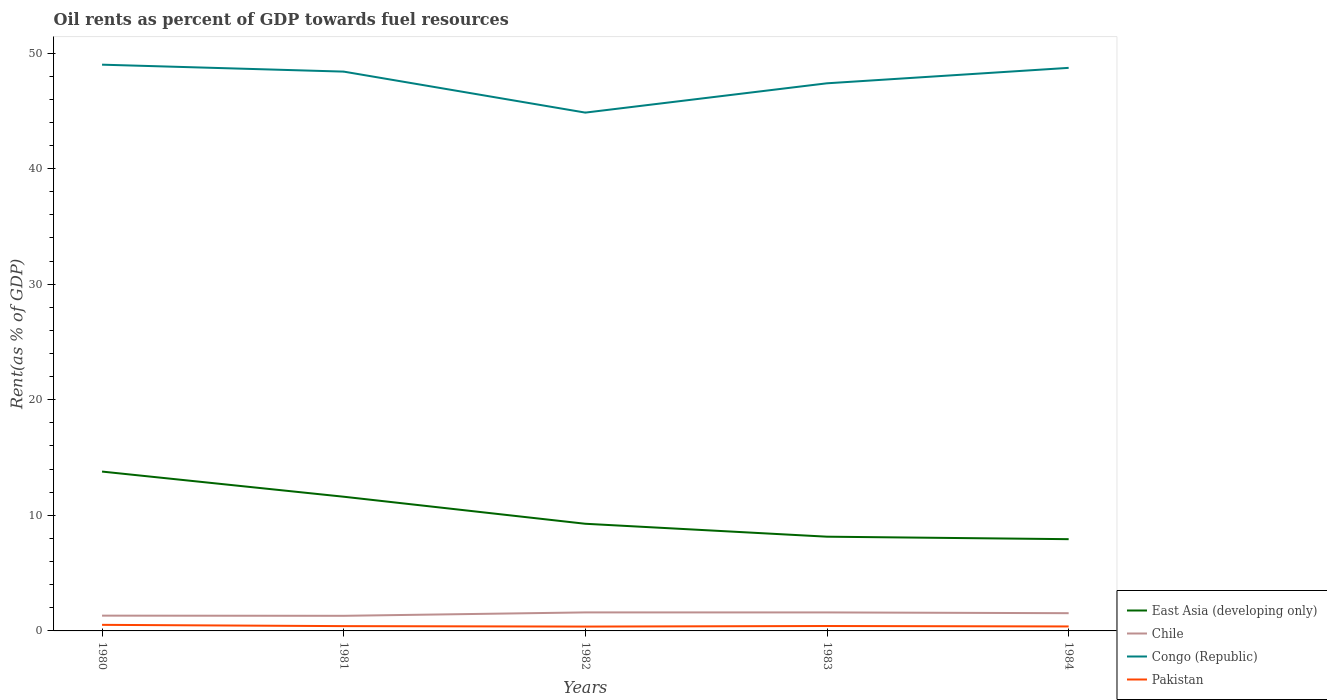Does the line corresponding to Congo (Republic) intersect with the line corresponding to Chile?
Keep it short and to the point. No. Across all years, what is the maximum oil rent in Chile?
Make the answer very short. 1.31. In which year was the oil rent in Pakistan maximum?
Make the answer very short. 1982. What is the total oil rent in Chile in the graph?
Provide a short and direct response. 0.02. What is the difference between the highest and the second highest oil rent in Pakistan?
Provide a succinct answer. 0.15. What is the difference between the highest and the lowest oil rent in Pakistan?
Your answer should be compact. 1. Is the oil rent in Pakistan strictly greater than the oil rent in Congo (Republic) over the years?
Keep it short and to the point. Yes. How many years are there in the graph?
Offer a very short reply. 5. What is the difference between two consecutive major ticks on the Y-axis?
Provide a short and direct response. 10. Does the graph contain any zero values?
Provide a succinct answer. No. Does the graph contain grids?
Your response must be concise. No. How are the legend labels stacked?
Your answer should be very brief. Vertical. What is the title of the graph?
Provide a succinct answer. Oil rents as percent of GDP towards fuel resources. What is the label or title of the Y-axis?
Your answer should be very brief. Rent(as % of GDP). What is the Rent(as % of GDP) of East Asia (developing only) in 1980?
Your response must be concise. 13.79. What is the Rent(as % of GDP) in Chile in 1980?
Your answer should be compact. 1.32. What is the Rent(as % of GDP) in Congo (Republic) in 1980?
Give a very brief answer. 48.99. What is the Rent(as % of GDP) of Pakistan in 1980?
Offer a terse response. 0.53. What is the Rent(as % of GDP) of East Asia (developing only) in 1981?
Keep it short and to the point. 11.61. What is the Rent(as % of GDP) of Chile in 1981?
Offer a very short reply. 1.31. What is the Rent(as % of GDP) in Congo (Republic) in 1981?
Offer a very short reply. 48.39. What is the Rent(as % of GDP) of Pakistan in 1981?
Offer a very short reply. 0.41. What is the Rent(as % of GDP) of East Asia (developing only) in 1982?
Give a very brief answer. 9.27. What is the Rent(as % of GDP) of Chile in 1982?
Offer a terse response. 1.6. What is the Rent(as % of GDP) in Congo (Republic) in 1982?
Your answer should be compact. 44.84. What is the Rent(as % of GDP) in Pakistan in 1982?
Your response must be concise. 0.38. What is the Rent(as % of GDP) of East Asia (developing only) in 1983?
Your response must be concise. 8.15. What is the Rent(as % of GDP) of Chile in 1983?
Your response must be concise. 1.6. What is the Rent(as % of GDP) in Congo (Republic) in 1983?
Provide a short and direct response. 47.38. What is the Rent(as % of GDP) in Pakistan in 1983?
Provide a short and direct response. 0.43. What is the Rent(as % of GDP) of East Asia (developing only) in 1984?
Offer a terse response. 7.94. What is the Rent(as % of GDP) of Chile in 1984?
Offer a terse response. 1.53. What is the Rent(as % of GDP) in Congo (Republic) in 1984?
Offer a terse response. 48.72. What is the Rent(as % of GDP) of Pakistan in 1984?
Your answer should be compact. 0.39. Across all years, what is the maximum Rent(as % of GDP) of East Asia (developing only)?
Give a very brief answer. 13.79. Across all years, what is the maximum Rent(as % of GDP) of Chile?
Provide a short and direct response. 1.6. Across all years, what is the maximum Rent(as % of GDP) in Congo (Republic)?
Your answer should be very brief. 48.99. Across all years, what is the maximum Rent(as % of GDP) in Pakistan?
Offer a terse response. 0.53. Across all years, what is the minimum Rent(as % of GDP) in East Asia (developing only)?
Offer a terse response. 7.94. Across all years, what is the minimum Rent(as % of GDP) in Chile?
Your answer should be very brief. 1.31. Across all years, what is the minimum Rent(as % of GDP) in Congo (Republic)?
Provide a succinct answer. 44.84. Across all years, what is the minimum Rent(as % of GDP) in Pakistan?
Keep it short and to the point. 0.38. What is the total Rent(as % of GDP) in East Asia (developing only) in the graph?
Provide a succinct answer. 50.76. What is the total Rent(as % of GDP) in Chile in the graph?
Provide a succinct answer. 7.36. What is the total Rent(as % of GDP) in Congo (Republic) in the graph?
Make the answer very short. 238.33. What is the total Rent(as % of GDP) of Pakistan in the graph?
Give a very brief answer. 2.13. What is the difference between the Rent(as % of GDP) of East Asia (developing only) in 1980 and that in 1981?
Your response must be concise. 2.18. What is the difference between the Rent(as % of GDP) of Chile in 1980 and that in 1981?
Offer a terse response. 0.02. What is the difference between the Rent(as % of GDP) of Congo (Republic) in 1980 and that in 1981?
Make the answer very short. 0.6. What is the difference between the Rent(as % of GDP) of Pakistan in 1980 and that in 1981?
Give a very brief answer. 0.11. What is the difference between the Rent(as % of GDP) in East Asia (developing only) in 1980 and that in 1982?
Give a very brief answer. 4.52. What is the difference between the Rent(as % of GDP) in Chile in 1980 and that in 1982?
Keep it short and to the point. -0.28. What is the difference between the Rent(as % of GDP) of Congo (Republic) in 1980 and that in 1982?
Provide a succinct answer. 4.15. What is the difference between the Rent(as % of GDP) in Pakistan in 1980 and that in 1982?
Make the answer very short. 0.15. What is the difference between the Rent(as % of GDP) in East Asia (developing only) in 1980 and that in 1983?
Offer a terse response. 5.63. What is the difference between the Rent(as % of GDP) of Chile in 1980 and that in 1983?
Offer a very short reply. -0.28. What is the difference between the Rent(as % of GDP) in Congo (Republic) in 1980 and that in 1983?
Ensure brevity in your answer.  1.61. What is the difference between the Rent(as % of GDP) in Pakistan in 1980 and that in 1983?
Your response must be concise. 0.1. What is the difference between the Rent(as % of GDP) of East Asia (developing only) in 1980 and that in 1984?
Your answer should be compact. 5.85. What is the difference between the Rent(as % of GDP) in Chile in 1980 and that in 1984?
Keep it short and to the point. -0.21. What is the difference between the Rent(as % of GDP) in Congo (Republic) in 1980 and that in 1984?
Offer a very short reply. 0.28. What is the difference between the Rent(as % of GDP) in Pakistan in 1980 and that in 1984?
Ensure brevity in your answer.  0.14. What is the difference between the Rent(as % of GDP) of East Asia (developing only) in 1981 and that in 1982?
Offer a terse response. 2.34. What is the difference between the Rent(as % of GDP) in Chile in 1981 and that in 1982?
Provide a short and direct response. -0.29. What is the difference between the Rent(as % of GDP) of Congo (Republic) in 1981 and that in 1982?
Your answer should be very brief. 3.55. What is the difference between the Rent(as % of GDP) of Pakistan in 1981 and that in 1982?
Provide a succinct answer. 0.04. What is the difference between the Rent(as % of GDP) of East Asia (developing only) in 1981 and that in 1983?
Your answer should be compact. 3.46. What is the difference between the Rent(as % of GDP) of Chile in 1981 and that in 1983?
Your response must be concise. -0.29. What is the difference between the Rent(as % of GDP) of Congo (Republic) in 1981 and that in 1983?
Offer a very short reply. 1.01. What is the difference between the Rent(as % of GDP) in Pakistan in 1981 and that in 1983?
Your response must be concise. -0.01. What is the difference between the Rent(as % of GDP) of East Asia (developing only) in 1981 and that in 1984?
Make the answer very short. 3.67. What is the difference between the Rent(as % of GDP) in Chile in 1981 and that in 1984?
Offer a very short reply. -0.23. What is the difference between the Rent(as % of GDP) of Congo (Republic) in 1981 and that in 1984?
Provide a succinct answer. -0.32. What is the difference between the Rent(as % of GDP) of Pakistan in 1981 and that in 1984?
Offer a terse response. 0.03. What is the difference between the Rent(as % of GDP) of East Asia (developing only) in 1982 and that in 1983?
Provide a short and direct response. 1.12. What is the difference between the Rent(as % of GDP) of Chile in 1982 and that in 1983?
Your response must be concise. 0. What is the difference between the Rent(as % of GDP) in Congo (Republic) in 1982 and that in 1983?
Your answer should be very brief. -2.54. What is the difference between the Rent(as % of GDP) of Pakistan in 1982 and that in 1983?
Keep it short and to the point. -0.05. What is the difference between the Rent(as % of GDP) of East Asia (developing only) in 1982 and that in 1984?
Provide a short and direct response. 1.33. What is the difference between the Rent(as % of GDP) of Chile in 1982 and that in 1984?
Provide a succinct answer. 0.07. What is the difference between the Rent(as % of GDP) of Congo (Republic) in 1982 and that in 1984?
Make the answer very short. -3.87. What is the difference between the Rent(as % of GDP) in Pakistan in 1982 and that in 1984?
Make the answer very short. -0.01. What is the difference between the Rent(as % of GDP) of East Asia (developing only) in 1983 and that in 1984?
Keep it short and to the point. 0.22. What is the difference between the Rent(as % of GDP) of Chile in 1983 and that in 1984?
Make the answer very short. 0.07. What is the difference between the Rent(as % of GDP) of Congo (Republic) in 1983 and that in 1984?
Your response must be concise. -1.34. What is the difference between the Rent(as % of GDP) of Pakistan in 1983 and that in 1984?
Keep it short and to the point. 0.04. What is the difference between the Rent(as % of GDP) of East Asia (developing only) in 1980 and the Rent(as % of GDP) of Chile in 1981?
Make the answer very short. 12.48. What is the difference between the Rent(as % of GDP) of East Asia (developing only) in 1980 and the Rent(as % of GDP) of Congo (Republic) in 1981?
Your answer should be compact. -34.61. What is the difference between the Rent(as % of GDP) of East Asia (developing only) in 1980 and the Rent(as % of GDP) of Pakistan in 1981?
Give a very brief answer. 13.37. What is the difference between the Rent(as % of GDP) in Chile in 1980 and the Rent(as % of GDP) in Congo (Republic) in 1981?
Provide a succinct answer. -47.07. What is the difference between the Rent(as % of GDP) in Chile in 1980 and the Rent(as % of GDP) in Pakistan in 1981?
Your response must be concise. 0.91. What is the difference between the Rent(as % of GDP) in Congo (Republic) in 1980 and the Rent(as % of GDP) in Pakistan in 1981?
Provide a succinct answer. 48.58. What is the difference between the Rent(as % of GDP) of East Asia (developing only) in 1980 and the Rent(as % of GDP) of Chile in 1982?
Offer a very short reply. 12.19. What is the difference between the Rent(as % of GDP) in East Asia (developing only) in 1980 and the Rent(as % of GDP) in Congo (Republic) in 1982?
Your response must be concise. -31.06. What is the difference between the Rent(as % of GDP) in East Asia (developing only) in 1980 and the Rent(as % of GDP) in Pakistan in 1982?
Offer a very short reply. 13.41. What is the difference between the Rent(as % of GDP) of Chile in 1980 and the Rent(as % of GDP) of Congo (Republic) in 1982?
Your answer should be very brief. -43.52. What is the difference between the Rent(as % of GDP) of Chile in 1980 and the Rent(as % of GDP) of Pakistan in 1982?
Your answer should be very brief. 0.95. What is the difference between the Rent(as % of GDP) in Congo (Republic) in 1980 and the Rent(as % of GDP) in Pakistan in 1982?
Make the answer very short. 48.62. What is the difference between the Rent(as % of GDP) in East Asia (developing only) in 1980 and the Rent(as % of GDP) in Chile in 1983?
Your answer should be very brief. 12.19. What is the difference between the Rent(as % of GDP) of East Asia (developing only) in 1980 and the Rent(as % of GDP) of Congo (Republic) in 1983?
Provide a short and direct response. -33.59. What is the difference between the Rent(as % of GDP) of East Asia (developing only) in 1980 and the Rent(as % of GDP) of Pakistan in 1983?
Give a very brief answer. 13.36. What is the difference between the Rent(as % of GDP) in Chile in 1980 and the Rent(as % of GDP) in Congo (Republic) in 1983?
Your answer should be very brief. -46.06. What is the difference between the Rent(as % of GDP) in Chile in 1980 and the Rent(as % of GDP) in Pakistan in 1983?
Your answer should be very brief. 0.9. What is the difference between the Rent(as % of GDP) in Congo (Republic) in 1980 and the Rent(as % of GDP) in Pakistan in 1983?
Provide a succinct answer. 48.57. What is the difference between the Rent(as % of GDP) in East Asia (developing only) in 1980 and the Rent(as % of GDP) in Chile in 1984?
Offer a very short reply. 12.25. What is the difference between the Rent(as % of GDP) of East Asia (developing only) in 1980 and the Rent(as % of GDP) of Congo (Republic) in 1984?
Your answer should be compact. -34.93. What is the difference between the Rent(as % of GDP) of East Asia (developing only) in 1980 and the Rent(as % of GDP) of Pakistan in 1984?
Ensure brevity in your answer.  13.4. What is the difference between the Rent(as % of GDP) in Chile in 1980 and the Rent(as % of GDP) in Congo (Republic) in 1984?
Provide a short and direct response. -47.39. What is the difference between the Rent(as % of GDP) of Chile in 1980 and the Rent(as % of GDP) of Pakistan in 1984?
Ensure brevity in your answer.  0.94. What is the difference between the Rent(as % of GDP) in Congo (Republic) in 1980 and the Rent(as % of GDP) in Pakistan in 1984?
Make the answer very short. 48.61. What is the difference between the Rent(as % of GDP) in East Asia (developing only) in 1981 and the Rent(as % of GDP) in Chile in 1982?
Give a very brief answer. 10.01. What is the difference between the Rent(as % of GDP) in East Asia (developing only) in 1981 and the Rent(as % of GDP) in Congo (Republic) in 1982?
Offer a very short reply. -33.23. What is the difference between the Rent(as % of GDP) of East Asia (developing only) in 1981 and the Rent(as % of GDP) of Pakistan in 1982?
Offer a very short reply. 11.23. What is the difference between the Rent(as % of GDP) in Chile in 1981 and the Rent(as % of GDP) in Congo (Republic) in 1982?
Your answer should be compact. -43.54. What is the difference between the Rent(as % of GDP) in Chile in 1981 and the Rent(as % of GDP) in Pakistan in 1982?
Provide a succinct answer. 0.93. What is the difference between the Rent(as % of GDP) of Congo (Republic) in 1981 and the Rent(as % of GDP) of Pakistan in 1982?
Your answer should be compact. 48.02. What is the difference between the Rent(as % of GDP) of East Asia (developing only) in 1981 and the Rent(as % of GDP) of Chile in 1983?
Ensure brevity in your answer.  10.01. What is the difference between the Rent(as % of GDP) of East Asia (developing only) in 1981 and the Rent(as % of GDP) of Congo (Republic) in 1983?
Your response must be concise. -35.77. What is the difference between the Rent(as % of GDP) of East Asia (developing only) in 1981 and the Rent(as % of GDP) of Pakistan in 1983?
Keep it short and to the point. 11.19. What is the difference between the Rent(as % of GDP) of Chile in 1981 and the Rent(as % of GDP) of Congo (Republic) in 1983?
Keep it short and to the point. -46.07. What is the difference between the Rent(as % of GDP) of Chile in 1981 and the Rent(as % of GDP) of Pakistan in 1983?
Give a very brief answer. 0.88. What is the difference between the Rent(as % of GDP) of Congo (Republic) in 1981 and the Rent(as % of GDP) of Pakistan in 1983?
Ensure brevity in your answer.  47.97. What is the difference between the Rent(as % of GDP) in East Asia (developing only) in 1981 and the Rent(as % of GDP) in Chile in 1984?
Give a very brief answer. 10.08. What is the difference between the Rent(as % of GDP) of East Asia (developing only) in 1981 and the Rent(as % of GDP) of Congo (Republic) in 1984?
Provide a short and direct response. -37.11. What is the difference between the Rent(as % of GDP) of East Asia (developing only) in 1981 and the Rent(as % of GDP) of Pakistan in 1984?
Ensure brevity in your answer.  11.22. What is the difference between the Rent(as % of GDP) in Chile in 1981 and the Rent(as % of GDP) in Congo (Republic) in 1984?
Ensure brevity in your answer.  -47.41. What is the difference between the Rent(as % of GDP) of Chile in 1981 and the Rent(as % of GDP) of Pakistan in 1984?
Your response must be concise. 0.92. What is the difference between the Rent(as % of GDP) of Congo (Republic) in 1981 and the Rent(as % of GDP) of Pakistan in 1984?
Your response must be concise. 48.01. What is the difference between the Rent(as % of GDP) in East Asia (developing only) in 1982 and the Rent(as % of GDP) in Chile in 1983?
Keep it short and to the point. 7.67. What is the difference between the Rent(as % of GDP) in East Asia (developing only) in 1982 and the Rent(as % of GDP) in Congo (Republic) in 1983?
Give a very brief answer. -38.11. What is the difference between the Rent(as % of GDP) in East Asia (developing only) in 1982 and the Rent(as % of GDP) in Pakistan in 1983?
Ensure brevity in your answer.  8.85. What is the difference between the Rent(as % of GDP) of Chile in 1982 and the Rent(as % of GDP) of Congo (Republic) in 1983?
Offer a very short reply. -45.78. What is the difference between the Rent(as % of GDP) in Chile in 1982 and the Rent(as % of GDP) in Pakistan in 1983?
Provide a succinct answer. 1.18. What is the difference between the Rent(as % of GDP) of Congo (Republic) in 1982 and the Rent(as % of GDP) of Pakistan in 1983?
Keep it short and to the point. 44.42. What is the difference between the Rent(as % of GDP) of East Asia (developing only) in 1982 and the Rent(as % of GDP) of Chile in 1984?
Keep it short and to the point. 7.74. What is the difference between the Rent(as % of GDP) in East Asia (developing only) in 1982 and the Rent(as % of GDP) in Congo (Republic) in 1984?
Provide a succinct answer. -39.45. What is the difference between the Rent(as % of GDP) of East Asia (developing only) in 1982 and the Rent(as % of GDP) of Pakistan in 1984?
Provide a short and direct response. 8.88. What is the difference between the Rent(as % of GDP) of Chile in 1982 and the Rent(as % of GDP) of Congo (Republic) in 1984?
Ensure brevity in your answer.  -47.12. What is the difference between the Rent(as % of GDP) in Chile in 1982 and the Rent(as % of GDP) in Pakistan in 1984?
Give a very brief answer. 1.21. What is the difference between the Rent(as % of GDP) of Congo (Republic) in 1982 and the Rent(as % of GDP) of Pakistan in 1984?
Ensure brevity in your answer.  44.46. What is the difference between the Rent(as % of GDP) of East Asia (developing only) in 1983 and the Rent(as % of GDP) of Chile in 1984?
Provide a short and direct response. 6.62. What is the difference between the Rent(as % of GDP) of East Asia (developing only) in 1983 and the Rent(as % of GDP) of Congo (Republic) in 1984?
Keep it short and to the point. -40.56. What is the difference between the Rent(as % of GDP) of East Asia (developing only) in 1983 and the Rent(as % of GDP) of Pakistan in 1984?
Ensure brevity in your answer.  7.77. What is the difference between the Rent(as % of GDP) of Chile in 1983 and the Rent(as % of GDP) of Congo (Republic) in 1984?
Provide a succinct answer. -47.12. What is the difference between the Rent(as % of GDP) in Chile in 1983 and the Rent(as % of GDP) in Pakistan in 1984?
Your answer should be compact. 1.21. What is the difference between the Rent(as % of GDP) of Congo (Republic) in 1983 and the Rent(as % of GDP) of Pakistan in 1984?
Provide a succinct answer. 46.99. What is the average Rent(as % of GDP) in East Asia (developing only) per year?
Give a very brief answer. 10.15. What is the average Rent(as % of GDP) of Chile per year?
Offer a very short reply. 1.47. What is the average Rent(as % of GDP) of Congo (Republic) per year?
Keep it short and to the point. 47.67. What is the average Rent(as % of GDP) of Pakistan per year?
Ensure brevity in your answer.  0.43. In the year 1980, what is the difference between the Rent(as % of GDP) of East Asia (developing only) and Rent(as % of GDP) of Chile?
Make the answer very short. 12.47. In the year 1980, what is the difference between the Rent(as % of GDP) in East Asia (developing only) and Rent(as % of GDP) in Congo (Republic)?
Your response must be concise. -35.21. In the year 1980, what is the difference between the Rent(as % of GDP) in East Asia (developing only) and Rent(as % of GDP) in Pakistan?
Ensure brevity in your answer.  13.26. In the year 1980, what is the difference between the Rent(as % of GDP) of Chile and Rent(as % of GDP) of Congo (Republic)?
Give a very brief answer. -47.67. In the year 1980, what is the difference between the Rent(as % of GDP) of Chile and Rent(as % of GDP) of Pakistan?
Offer a very short reply. 0.8. In the year 1980, what is the difference between the Rent(as % of GDP) of Congo (Republic) and Rent(as % of GDP) of Pakistan?
Offer a terse response. 48.47. In the year 1981, what is the difference between the Rent(as % of GDP) of East Asia (developing only) and Rent(as % of GDP) of Chile?
Your answer should be very brief. 10.3. In the year 1981, what is the difference between the Rent(as % of GDP) of East Asia (developing only) and Rent(as % of GDP) of Congo (Republic)?
Offer a terse response. -36.78. In the year 1981, what is the difference between the Rent(as % of GDP) of East Asia (developing only) and Rent(as % of GDP) of Pakistan?
Provide a short and direct response. 11.2. In the year 1981, what is the difference between the Rent(as % of GDP) of Chile and Rent(as % of GDP) of Congo (Republic)?
Offer a terse response. -47.09. In the year 1981, what is the difference between the Rent(as % of GDP) of Chile and Rent(as % of GDP) of Pakistan?
Your answer should be compact. 0.89. In the year 1981, what is the difference between the Rent(as % of GDP) in Congo (Republic) and Rent(as % of GDP) in Pakistan?
Your answer should be very brief. 47.98. In the year 1982, what is the difference between the Rent(as % of GDP) in East Asia (developing only) and Rent(as % of GDP) in Chile?
Offer a very short reply. 7.67. In the year 1982, what is the difference between the Rent(as % of GDP) in East Asia (developing only) and Rent(as % of GDP) in Congo (Republic)?
Your response must be concise. -35.57. In the year 1982, what is the difference between the Rent(as % of GDP) in East Asia (developing only) and Rent(as % of GDP) in Pakistan?
Provide a succinct answer. 8.9. In the year 1982, what is the difference between the Rent(as % of GDP) of Chile and Rent(as % of GDP) of Congo (Republic)?
Provide a short and direct response. -43.24. In the year 1982, what is the difference between the Rent(as % of GDP) in Chile and Rent(as % of GDP) in Pakistan?
Your response must be concise. 1.23. In the year 1982, what is the difference between the Rent(as % of GDP) in Congo (Republic) and Rent(as % of GDP) in Pakistan?
Your response must be concise. 44.47. In the year 1983, what is the difference between the Rent(as % of GDP) of East Asia (developing only) and Rent(as % of GDP) of Chile?
Give a very brief answer. 6.55. In the year 1983, what is the difference between the Rent(as % of GDP) of East Asia (developing only) and Rent(as % of GDP) of Congo (Republic)?
Provide a succinct answer. -39.23. In the year 1983, what is the difference between the Rent(as % of GDP) in East Asia (developing only) and Rent(as % of GDP) in Pakistan?
Give a very brief answer. 7.73. In the year 1983, what is the difference between the Rent(as % of GDP) of Chile and Rent(as % of GDP) of Congo (Republic)?
Your answer should be compact. -45.78. In the year 1983, what is the difference between the Rent(as % of GDP) in Chile and Rent(as % of GDP) in Pakistan?
Your answer should be very brief. 1.18. In the year 1983, what is the difference between the Rent(as % of GDP) of Congo (Republic) and Rent(as % of GDP) of Pakistan?
Ensure brevity in your answer.  46.96. In the year 1984, what is the difference between the Rent(as % of GDP) in East Asia (developing only) and Rent(as % of GDP) in Chile?
Make the answer very short. 6.4. In the year 1984, what is the difference between the Rent(as % of GDP) of East Asia (developing only) and Rent(as % of GDP) of Congo (Republic)?
Offer a terse response. -40.78. In the year 1984, what is the difference between the Rent(as % of GDP) in East Asia (developing only) and Rent(as % of GDP) in Pakistan?
Provide a succinct answer. 7.55. In the year 1984, what is the difference between the Rent(as % of GDP) in Chile and Rent(as % of GDP) in Congo (Republic)?
Your response must be concise. -47.18. In the year 1984, what is the difference between the Rent(as % of GDP) of Chile and Rent(as % of GDP) of Pakistan?
Keep it short and to the point. 1.15. In the year 1984, what is the difference between the Rent(as % of GDP) in Congo (Republic) and Rent(as % of GDP) in Pakistan?
Offer a very short reply. 48.33. What is the ratio of the Rent(as % of GDP) in East Asia (developing only) in 1980 to that in 1981?
Ensure brevity in your answer.  1.19. What is the ratio of the Rent(as % of GDP) in Chile in 1980 to that in 1981?
Provide a succinct answer. 1.01. What is the ratio of the Rent(as % of GDP) of Congo (Republic) in 1980 to that in 1981?
Your answer should be very brief. 1.01. What is the ratio of the Rent(as % of GDP) in Pakistan in 1980 to that in 1981?
Offer a terse response. 1.27. What is the ratio of the Rent(as % of GDP) in East Asia (developing only) in 1980 to that in 1982?
Offer a terse response. 1.49. What is the ratio of the Rent(as % of GDP) of Chile in 1980 to that in 1982?
Provide a short and direct response. 0.83. What is the ratio of the Rent(as % of GDP) in Congo (Republic) in 1980 to that in 1982?
Give a very brief answer. 1.09. What is the ratio of the Rent(as % of GDP) in Pakistan in 1980 to that in 1982?
Your answer should be compact. 1.4. What is the ratio of the Rent(as % of GDP) of East Asia (developing only) in 1980 to that in 1983?
Offer a terse response. 1.69. What is the ratio of the Rent(as % of GDP) of Chile in 1980 to that in 1983?
Your answer should be very brief. 0.83. What is the ratio of the Rent(as % of GDP) of Congo (Republic) in 1980 to that in 1983?
Keep it short and to the point. 1.03. What is the ratio of the Rent(as % of GDP) in Pakistan in 1980 to that in 1983?
Offer a very short reply. 1.24. What is the ratio of the Rent(as % of GDP) of East Asia (developing only) in 1980 to that in 1984?
Offer a terse response. 1.74. What is the ratio of the Rent(as % of GDP) in Chile in 1980 to that in 1984?
Make the answer very short. 0.86. What is the ratio of the Rent(as % of GDP) in Pakistan in 1980 to that in 1984?
Ensure brevity in your answer.  1.36. What is the ratio of the Rent(as % of GDP) of East Asia (developing only) in 1981 to that in 1982?
Offer a very short reply. 1.25. What is the ratio of the Rent(as % of GDP) in Chile in 1981 to that in 1982?
Your answer should be compact. 0.82. What is the ratio of the Rent(as % of GDP) in Congo (Republic) in 1981 to that in 1982?
Give a very brief answer. 1.08. What is the ratio of the Rent(as % of GDP) of Pakistan in 1981 to that in 1982?
Your response must be concise. 1.1. What is the ratio of the Rent(as % of GDP) of East Asia (developing only) in 1981 to that in 1983?
Offer a terse response. 1.42. What is the ratio of the Rent(as % of GDP) in Chile in 1981 to that in 1983?
Offer a terse response. 0.82. What is the ratio of the Rent(as % of GDP) in Congo (Republic) in 1981 to that in 1983?
Give a very brief answer. 1.02. What is the ratio of the Rent(as % of GDP) in Pakistan in 1981 to that in 1983?
Your answer should be very brief. 0.97. What is the ratio of the Rent(as % of GDP) in East Asia (developing only) in 1981 to that in 1984?
Make the answer very short. 1.46. What is the ratio of the Rent(as % of GDP) of Chile in 1981 to that in 1984?
Your answer should be very brief. 0.85. What is the ratio of the Rent(as % of GDP) in Pakistan in 1981 to that in 1984?
Provide a succinct answer. 1.07. What is the ratio of the Rent(as % of GDP) in East Asia (developing only) in 1982 to that in 1983?
Your answer should be very brief. 1.14. What is the ratio of the Rent(as % of GDP) of Chile in 1982 to that in 1983?
Provide a succinct answer. 1. What is the ratio of the Rent(as % of GDP) of Congo (Republic) in 1982 to that in 1983?
Your response must be concise. 0.95. What is the ratio of the Rent(as % of GDP) in Pakistan in 1982 to that in 1983?
Keep it short and to the point. 0.88. What is the ratio of the Rent(as % of GDP) of East Asia (developing only) in 1982 to that in 1984?
Your answer should be very brief. 1.17. What is the ratio of the Rent(as % of GDP) in Chile in 1982 to that in 1984?
Keep it short and to the point. 1.04. What is the ratio of the Rent(as % of GDP) of Congo (Republic) in 1982 to that in 1984?
Ensure brevity in your answer.  0.92. What is the ratio of the Rent(as % of GDP) of Pakistan in 1982 to that in 1984?
Ensure brevity in your answer.  0.97. What is the ratio of the Rent(as % of GDP) in East Asia (developing only) in 1983 to that in 1984?
Make the answer very short. 1.03. What is the ratio of the Rent(as % of GDP) in Chile in 1983 to that in 1984?
Ensure brevity in your answer.  1.04. What is the ratio of the Rent(as % of GDP) in Congo (Republic) in 1983 to that in 1984?
Offer a terse response. 0.97. What is the ratio of the Rent(as % of GDP) in Pakistan in 1983 to that in 1984?
Provide a succinct answer. 1.1. What is the difference between the highest and the second highest Rent(as % of GDP) of East Asia (developing only)?
Offer a terse response. 2.18. What is the difference between the highest and the second highest Rent(as % of GDP) of Chile?
Give a very brief answer. 0. What is the difference between the highest and the second highest Rent(as % of GDP) of Congo (Republic)?
Give a very brief answer. 0.28. What is the difference between the highest and the second highest Rent(as % of GDP) of Pakistan?
Give a very brief answer. 0.1. What is the difference between the highest and the lowest Rent(as % of GDP) in East Asia (developing only)?
Offer a terse response. 5.85. What is the difference between the highest and the lowest Rent(as % of GDP) of Chile?
Your answer should be very brief. 0.29. What is the difference between the highest and the lowest Rent(as % of GDP) in Congo (Republic)?
Offer a very short reply. 4.15. What is the difference between the highest and the lowest Rent(as % of GDP) of Pakistan?
Give a very brief answer. 0.15. 